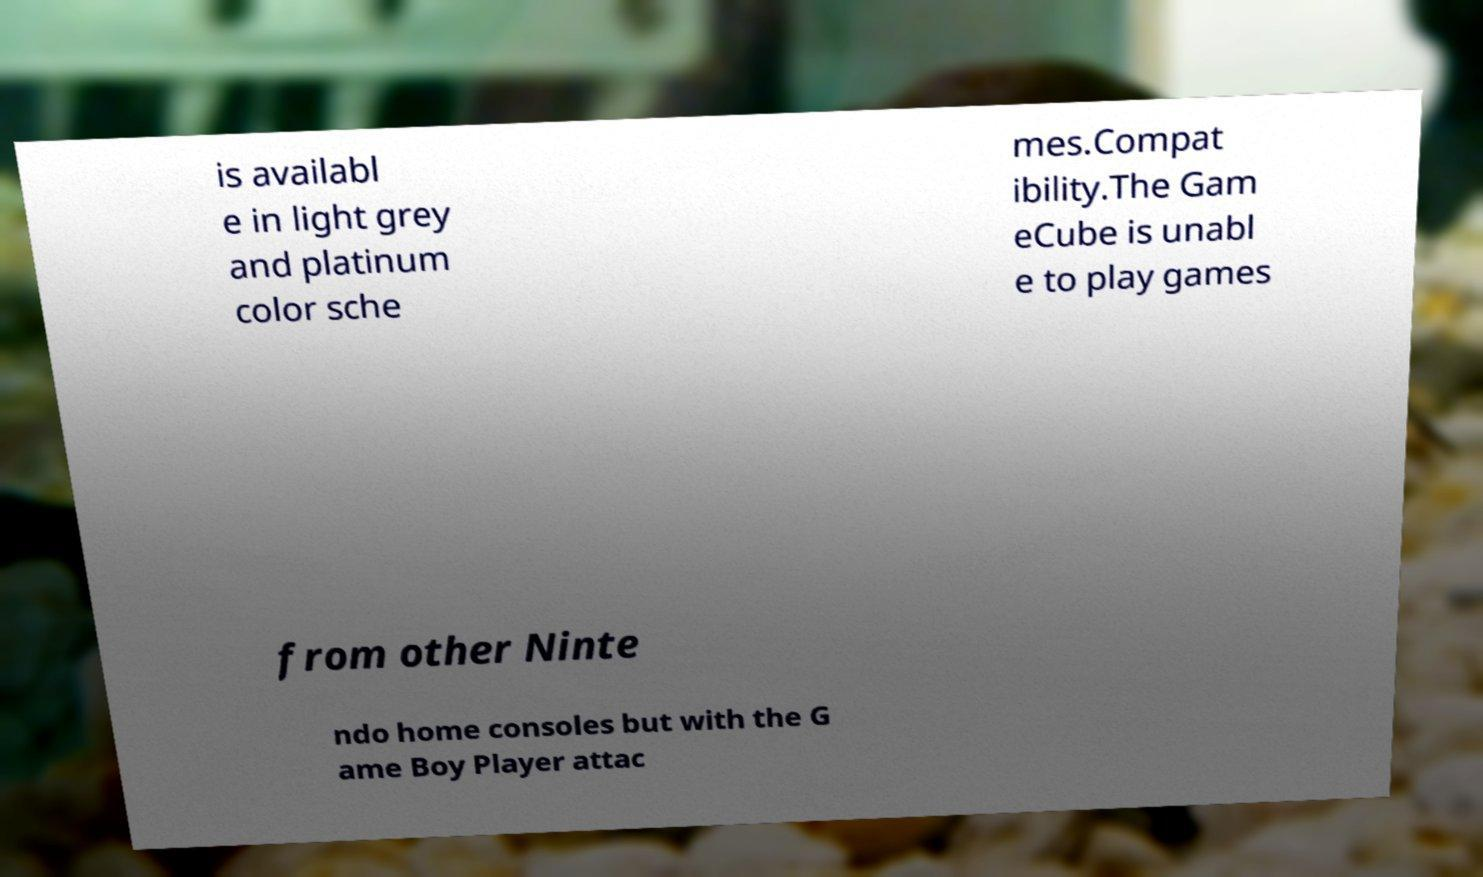I need the written content from this picture converted into text. Can you do that? is availabl e in light grey and platinum color sche mes.Compat ibility.The Gam eCube is unabl e to play games from other Ninte ndo home consoles but with the G ame Boy Player attac 